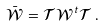Convert formula to latex. <formula><loc_0><loc_0><loc_500><loc_500>\bar { \mathcal { W } } = \mathcal { T } \mathcal { W } ^ { t } \mathcal { T } \, .</formula> 